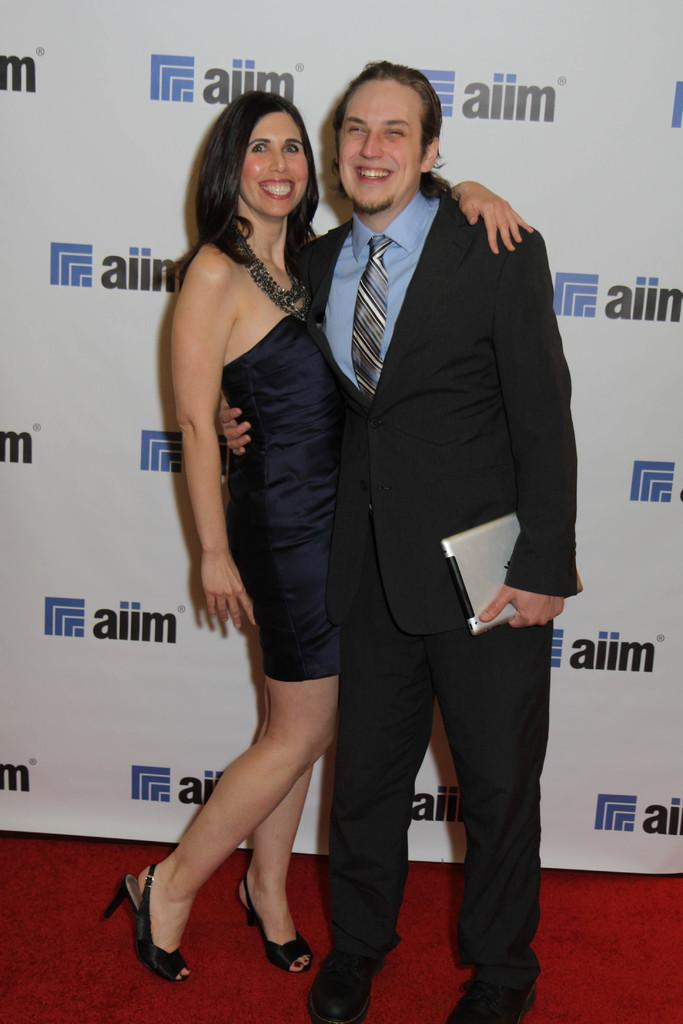Who are the two people in the center of the image? There is a man and a woman standing in the center of the image. What is behind the man and woman? There is a banner behind the man and woman. What is at the bottom of the image? There is a red carpet at the bottom of the image. Where is the maid standing in the image? There is no maid present in the image. How many wings are visible on the man in the image? The man in the image does not have any wings. 